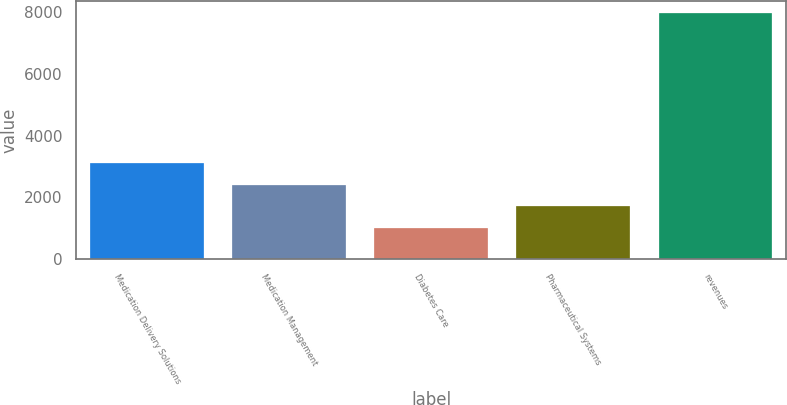<chart> <loc_0><loc_0><loc_500><loc_500><bar_chart><fcel>Medication Delivery Solutions<fcel>Medication Management<fcel>Diabetes Care<fcel>Pharmaceutical Systems<fcel>revenues<nl><fcel>3105.6<fcel>2411.4<fcel>1023<fcel>1717.2<fcel>7965<nl></chart> 